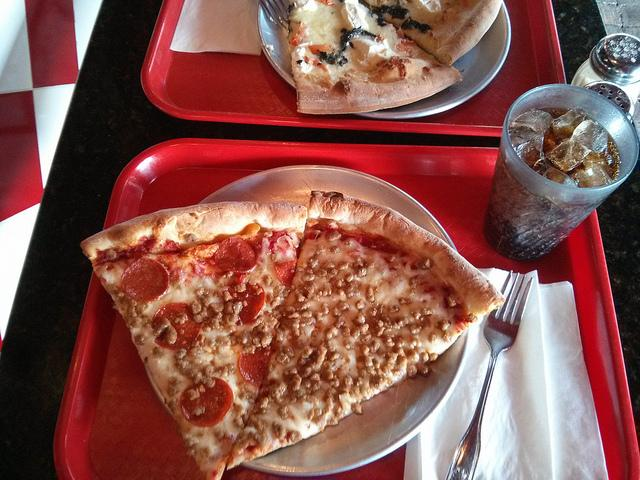Where was this pizza purchased? restaurant 